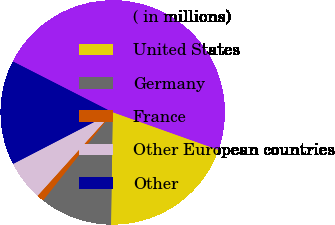Convert chart to OTSL. <chart><loc_0><loc_0><loc_500><loc_500><pie_chart><fcel>( in millions)<fcel>United States<fcel>Germany<fcel>France<fcel>Other European countries<fcel>Other<nl><fcel>47.93%<fcel>19.79%<fcel>10.41%<fcel>1.03%<fcel>5.72%<fcel>15.1%<nl></chart> 